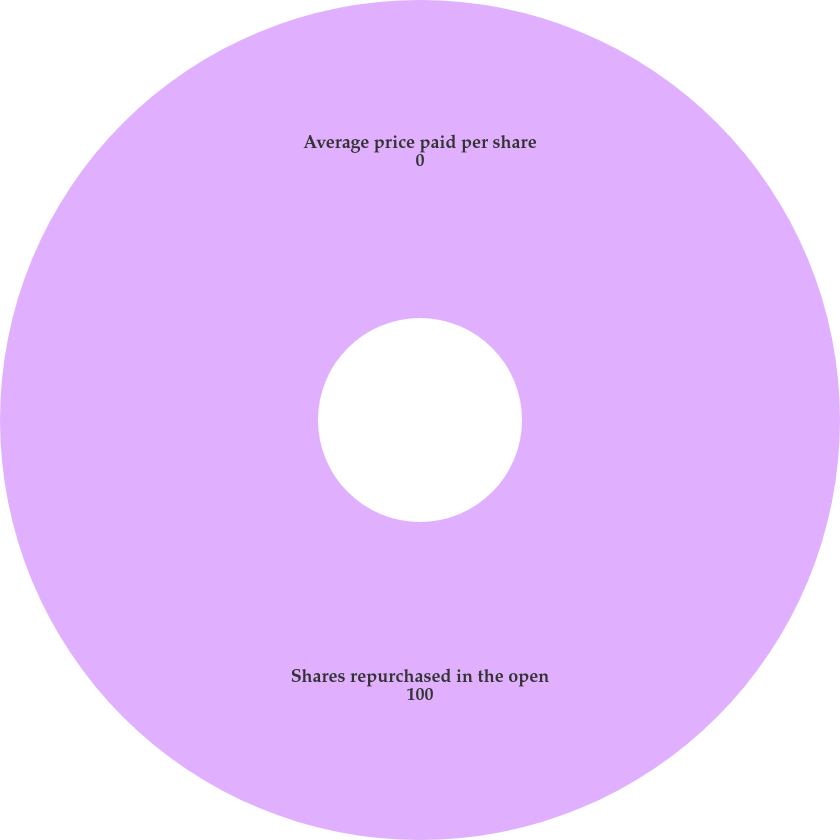<chart> <loc_0><loc_0><loc_500><loc_500><pie_chart><fcel>Shares repurchased in the open<fcel>Average price paid per share<nl><fcel>100.0%<fcel>0.0%<nl></chart> 